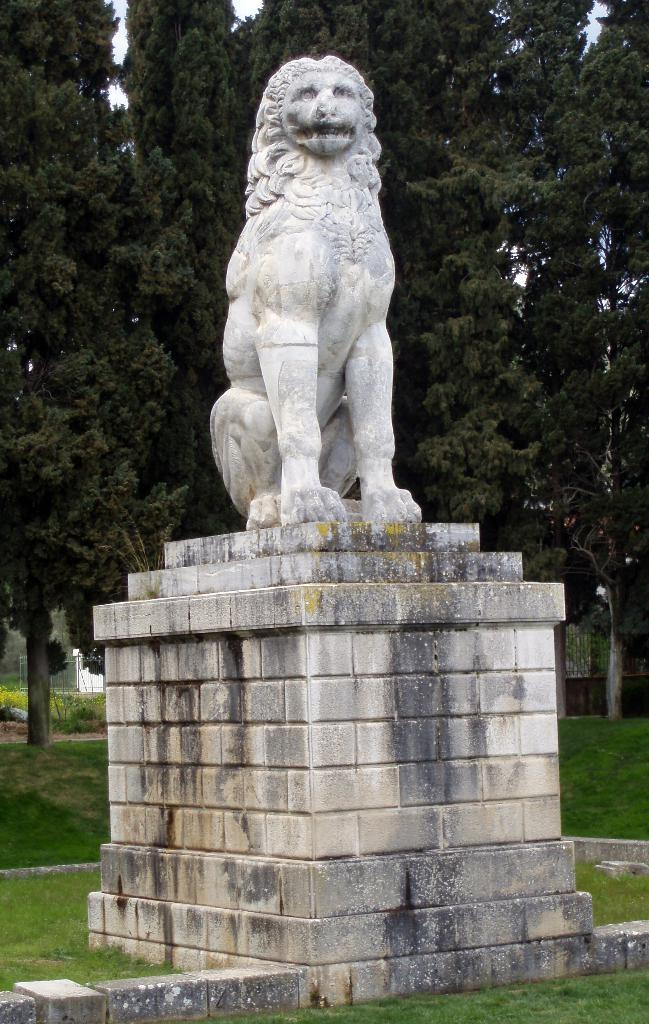Where was the picture taken? The picture was clicked outside. What is the main subject in the center of the image? There is a sculpture of a lion in the center of the image. What type of vegetation can be seen in the image? There is green grass in the image. What can be seen in the background of the image? There are trees, the sky, plants, and other objects in the background of the image. What type of thrill can be seen in the image? There is no thrill present in the image; it features a sculpture of a lion, green grass, and various objects in the background. What trick is the lion performing in the image? There is no trick being performed by the lion in the image; it is a static sculpture. 